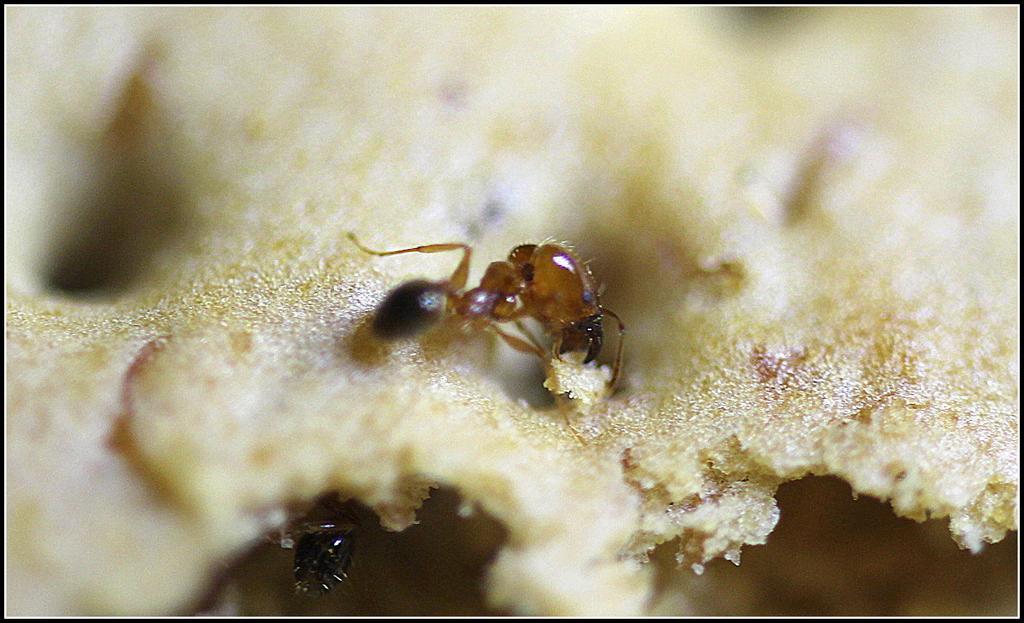Can you describe this image briefly? Here we can see ants on food. Background it is blur. 